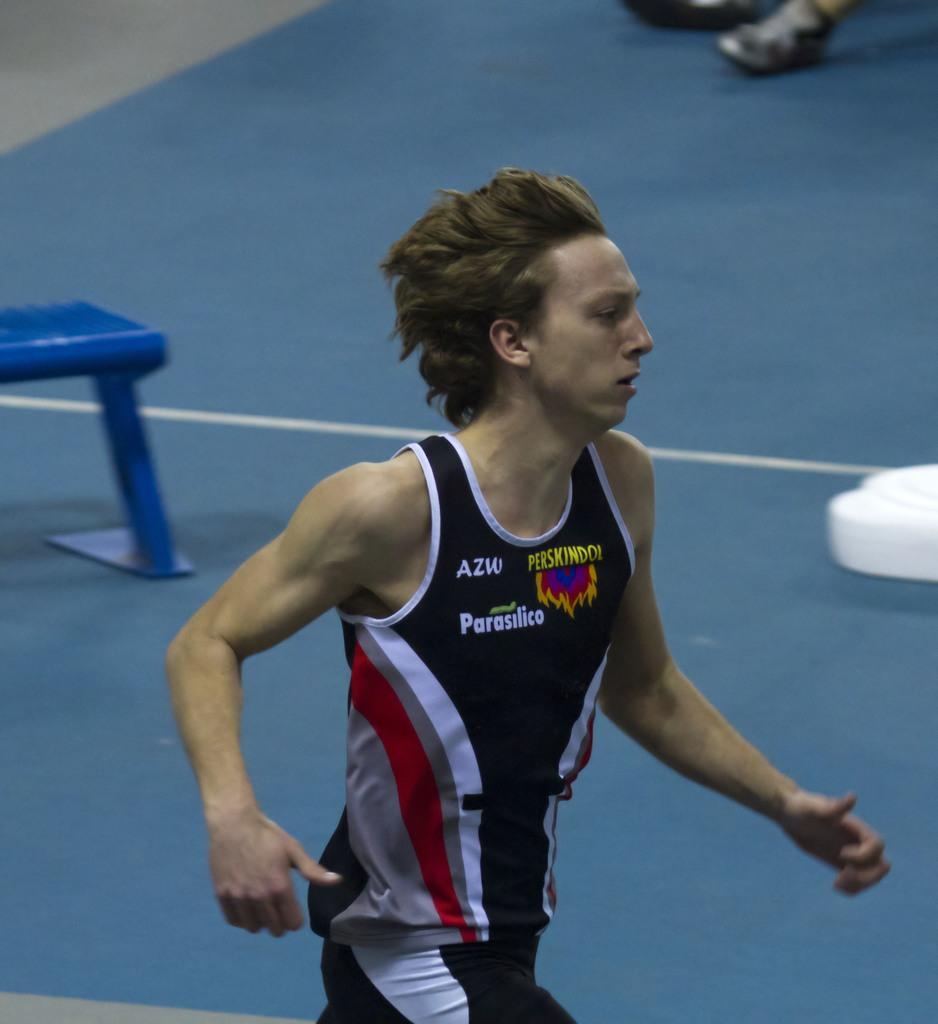<image>
Write a terse but informative summary of the picture. A man runs with a jersey on with AZW, Parasilico, and Perskindo logos on it. 